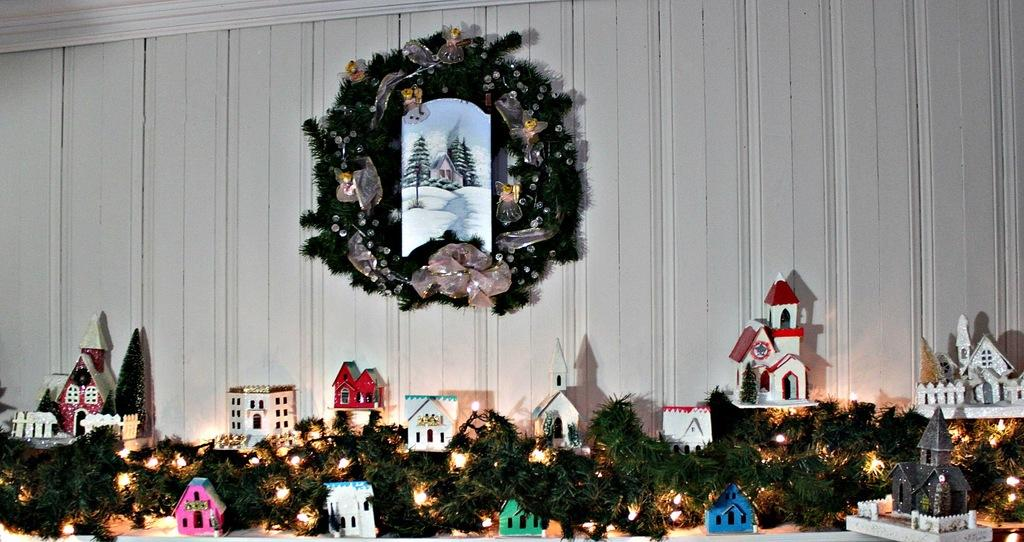What decorative item is hanging on the wall in the image? There is a wreath on the wall in the image. What can be seen providing illumination in the image? There are lights visible in the image. What type of structure is present in the image? There is a house in the image. What type of creature can be seen making a discovery in the image? There is no creature present in the image, nor is there any indication of a discovery being made. 